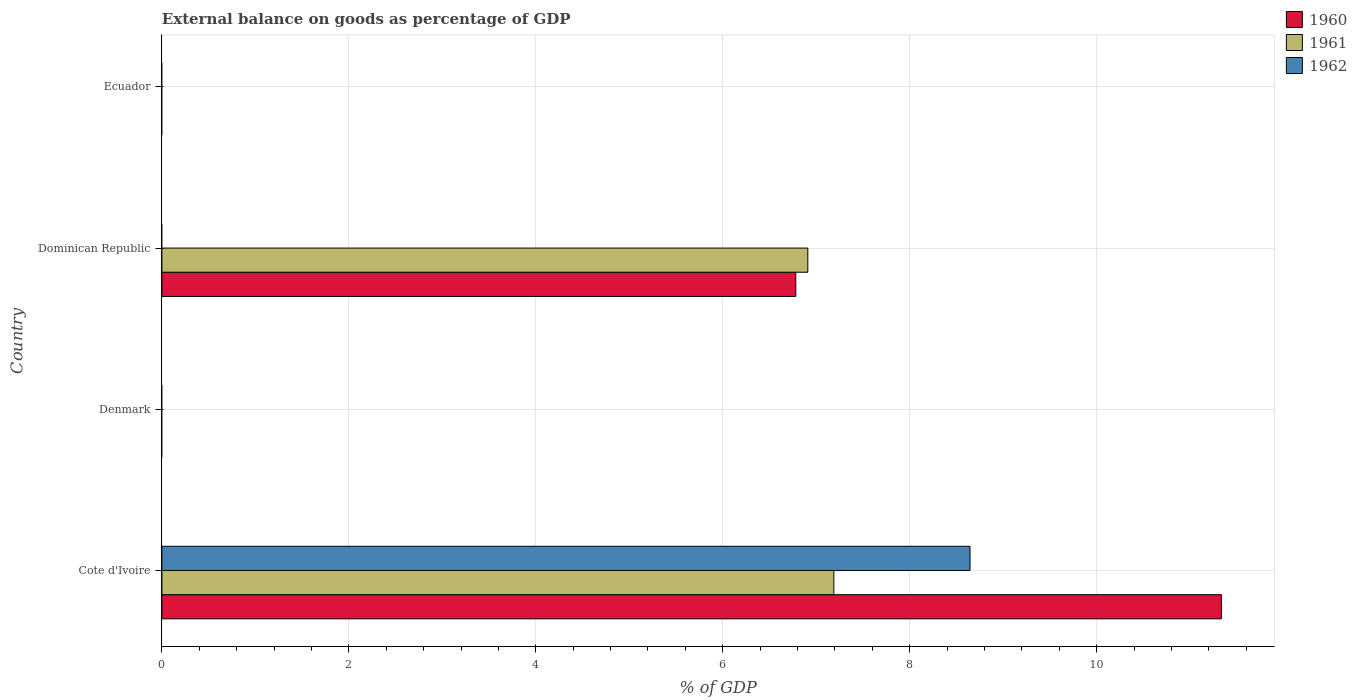Are the number of bars per tick equal to the number of legend labels?
Your answer should be very brief. No. How many bars are there on the 2nd tick from the bottom?
Provide a short and direct response. 0. In how many cases, is the number of bars for a given country not equal to the number of legend labels?
Your response must be concise. 3. What is the external balance on goods as percentage of GDP in 1962 in Ecuador?
Your response must be concise. 0. Across all countries, what is the maximum external balance on goods as percentage of GDP in 1961?
Your answer should be compact. 7.19. Across all countries, what is the minimum external balance on goods as percentage of GDP in 1961?
Give a very brief answer. 0. In which country was the external balance on goods as percentage of GDP in 1960 maximum?
Your answer should be compact. Cote d'Ivoire. What is the total external balance on goods as percentage of GDP in 1960 in the graph?
Keep it short and to the point. 18.12. What is the difference between the external balance on goods as percentage of GDP in 1961 in Denmark and the external balance on goods as percentage of GDP in 1962 in Cote d'Ivoire?
Ensure brevity in your answer.  -8.65. What is the average external balance on goods as percentage of GDP in 1961 per country?
Give a very brief answer. 3.52. What is the difference between the external balance on goods as percentage of GDP in 1960 and external balance on goods as percentage of GDP in 1962 in Cote d'Ivoire?
Give a very brief answer. 2.69. What is the ratio of the external balance on goods as percentage of GDP in 1961 in Cote d'Ivoire to that in Dominican Republic?
Your answer should be very brief. 1.04. Is the external balance on goods as percentage of GDP in 1960 in Cote d'Ivoire less than that in Dominican Republic?
Your answer should be very brief. No. What is the difference between the highest and the lowest external balance on goods as percentage of GDP in 1962?
Your answer should be very brief. 8.65. In how many countries, is the external balance on goods as percentage of GDP in 1962 greater than the average external balance on goods as percentage of GDP in 1962 taken over all countries?
Give a very brief answer. 1. Is the sum of the external balance on goods as percentage of GDP in 1960 in Cote d'Ivoire and Dominican Republic greater than the maximum external balance on goods as percentage of GDP in 1961 across all countries?
Make the answer very short. Yes. Is it the case that in every country, the sum of the external balance on goods as percentage of GDP in 1962 and external balance on goods as percentage of GDP in 1961 is greater than the external balance on goods as percentage of GDP in 1960?
Keep it short and to the point. No. How many bars are there?
Your answer should be very brief. 5. Are all the bars in the graph horizontal?
Provide a succinct answer. Yes. How many countries are there in the graph?
Your response must be concise. 4. Are the values on the major ticks of X-axis written in scientific E-notation?
Make the answer very short. No. Does the graph contain any zero values?
Your answer should be very brief. Yes. How many legend labels are there?
Ensure brevity in your answer.  3. How are the legend labels stacked?
Your response must be concise. Vertical. What is the title of the graph?
Keep it short and to the point. External balance on goods as percentage of GDP. What is the label or title of the X-axis?
Your answer should be compact. % of GDP. What is the label or title of the Y-axis?
Provide a short and direct response. Country. What is the % of GDP of 1960 in Cote d'Ivoire?
Your answer should be compact. 11.34. What is the % of GDP in 1961 in Cote d'Ivoire?
Provide a short and direct response. 7.19. What is the % of GDP of 1962 in Cote d'Ivoire?
Make the answer very short. 8.65. What is the % of GDP in 1960 in Denmark?
Provide a short and direct response. 0. What is the % of GDP of 1961 in Denmark?
Provide a short and direct response. 0. What is the % of GDP in 1962 in Denmark?
Give a very brief answer. 0. What is the % of GDP of 1960 in Dominican Republic?
Offer a very short reply. 6.78. What is the % of GDP of 1961 in Dominican Republic?
Offer a terse response. 6.91. What is the % of GDP of 1961 in Ecuador?
Provide a succinct answer. 0. What is the % of GDP of 1962 in Ecuador?
Keep it short and to the point. 0. Across all countries, what is the maximum % of GDP of 1960?
Your response must be concise. 11.34. Across all countries, what is the maximum % of GDP in 1961?
Keep it short and to the point. 7.19. Across all countries, what is the maximum % of GDP of 1962?
Provide a succinct answer. 8.65. Across all countries, what is the minimum % of GDP in 1960?
Ensure brevity in your answer.  0. Across all countries, what is the minimum % of GDP of 1962?
Give a very brief answer. 0. What is the total % of GDP in 1960 in the graph?
Make the answer very short. 18.12. What is the total % of GDP in 1961 in the graph?
Your response must be concise. 14.1. What is the total % of GDP of 1962 in the graph?
Provide a short and direct response. 8.65. What is the difference between the % of GDP in 1960 in Cote d'Ivoire and that in Dominican Republic?
Provide a succinct answer. 4.55. What is the difference between the % of GDP in 1961 in Cote d'Ivoire and that in Dominican Republic?
Your response must be concise. 0.28. What is the difference between the % of GDP of 1960 in Cote d'Ivoire and the % of GDP of 1961 in Dominican Republic?
Provide a short and direct response. 4.42. What is the average % of GDP in 1960 per country?
Offer a terse response. 4.53. What is the average % of GDP of 1961 per country?
Ensure brevity in your answer.  3.52. What is the average % of GDP of 1962 per country?
Your response must be concise. 2.16. What is the difference between the % of GDP in 1960 and % of GDP in 1961 in Cote d'Ivoire?
Offer a very short reply. 4.15. What is the difference between the % of GDP of 1960 and % of GDP of 1962 in Cote d'Ivoire?
Keep it short and to the point. 2.69. What is the difference between the % of GDP in 1961 and % of GDP in 1962 in Cote d'Ivoire?
Offer a terse response. -1.46. What is the difference between the % of GDP of 1960 and % of GDP of 1961 in Dominican Republic?
Give a very brief answer. -0.13. What is the ratio of the % of GDP of 1960 in Cote d'Ivoire to that in Dominican Republic?
Your response must be concise. 1.67. What is the ratio of the % of GDP of 1961 in Cote d'Ivoire to that in Dominican Republic?
Make the answer very short. 1.04. What is the difference between the highest and the lowest % of GDP of 1960?
Keep it short and to the point. 11.34. What is the difference between the highest and the lowest % of GDP of 1961?
Keep it short and to the point. 7.19. What is the difference between the highest and the lowest % of GDP in 1962?
Your response must be concise. 8.65. 